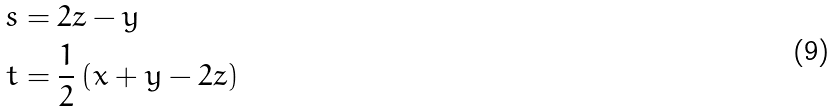<formula> <loc_0><loc_0><loc_500><loc_500>s & = 2 z - y \\ t & = \frac { 1 } { 2 } \, ( x + y - 2 z )</formula> 